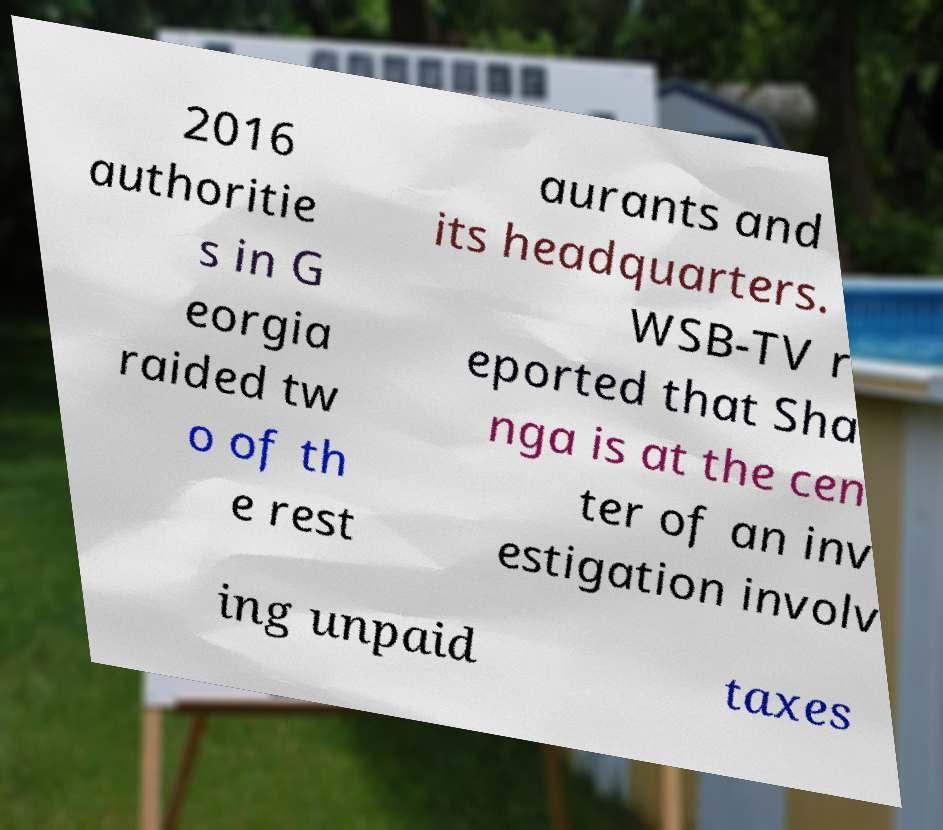Please identify and transcribe the text found in this image. 2016 authoritie s in G eorgia raided tw o of th e rest aurants and its headquarters. WSB-TV r eported that Sha nga is at the cen ter of an inv estigation involv ing unpaid taxes 